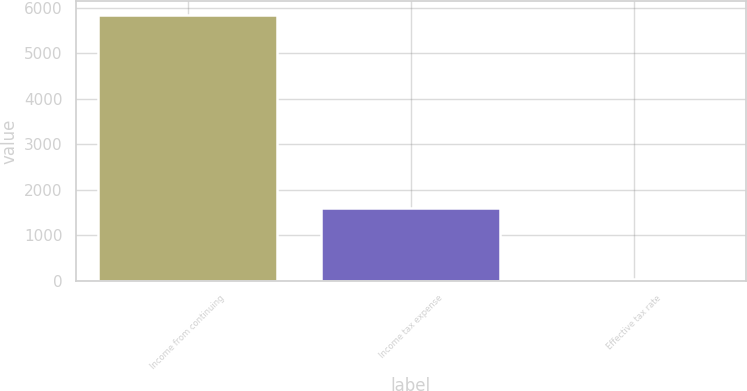<chart> <loc_0><loc_0><loc_500><loc_500><bar_chart><fcel>Income from continuing<fcel>Income tax expense<fcel>Effective tax rate<nl><fcel>5856<fcel>1596<fcel>27.3<nl></chart> 